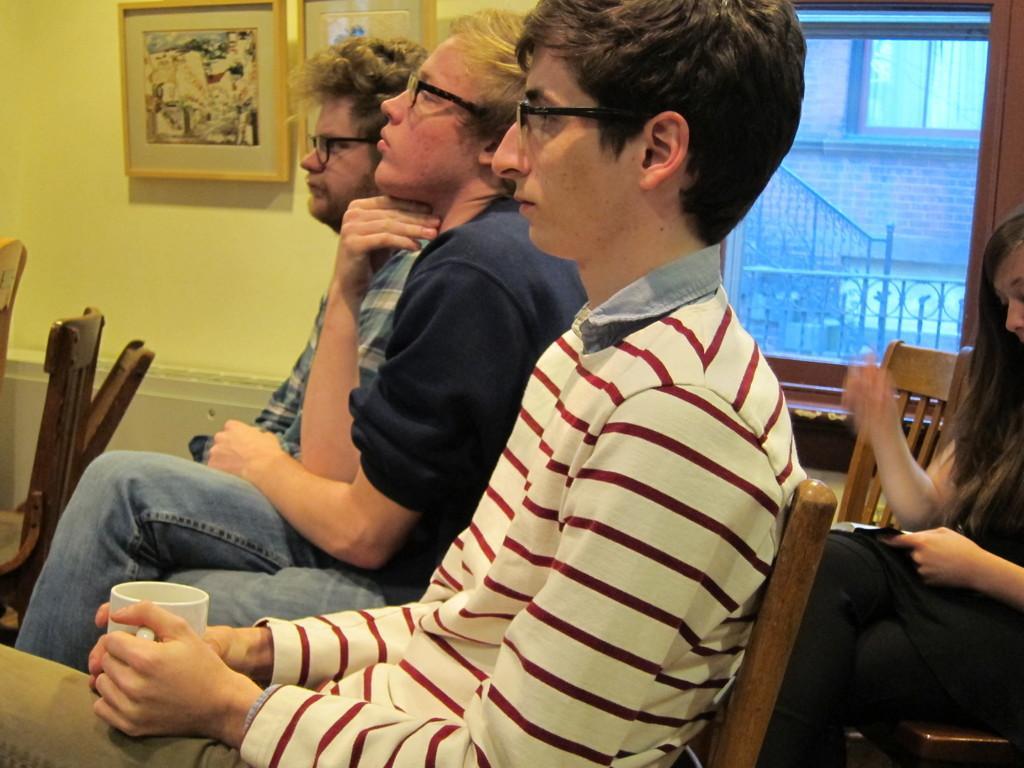Please provide a concise description of this image. In this image there are people are sitting on chairs, in the background there is a wall to that wall there is a window and frames. 